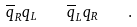Convert formula to latex. <formula><loc_0><loc_0><loc_500><loc_500>\overline { q } _ { R } q _ { L } \quad \overline { q } _ { L } q _ { R } \quad .</formula> 